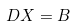<formula> <loc_0><loc_0><loc_500><loc_500>D X = B</formula> 